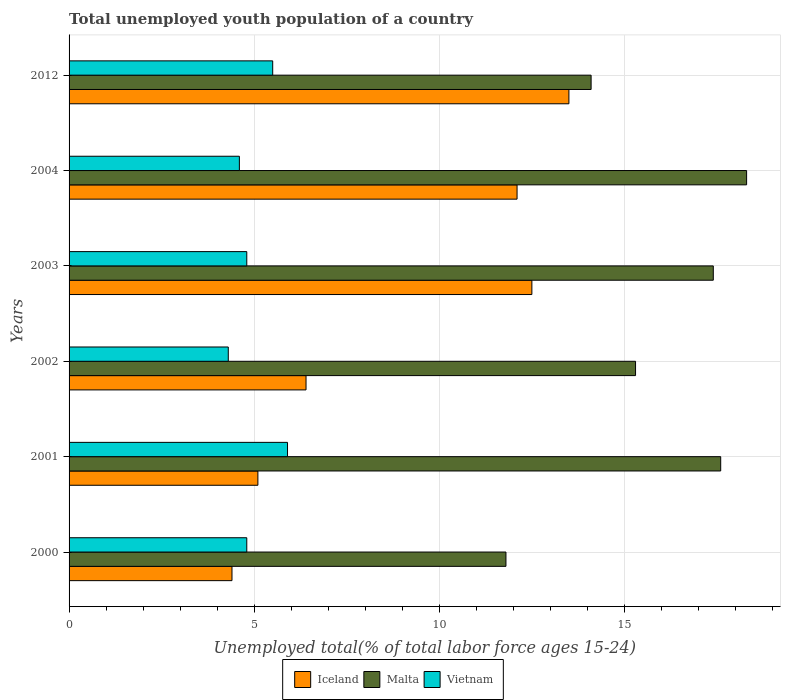How many groups of bars are there?
Give a very brief answer. 6. How many bars are there on the 5th tick from the top?
Provide a short and direct response. 3. How many bars are there on the 1st tick from the bottom?
Offer a very short reply. 3. What is the label of the 3rd group of bars from the top?
Give a very brief answer. 2003. In how many cases, is the number of bars for a given year not equal to the number of legend labels?
Make the answer very short. 0. What is the percentage of total unemployed youth population of a country in Vietnam in 2004?
Keep it short and to the point. 4.6. Across all years, what is the minimum percentage of total unemployed youth population of a country in Vietnam?
Give a very brief answer. 4.3. In which year was the percentage of total unemployed youth population of a country in Malta maximum?
Your answer should be compact. 2004. What is the total percentage of total unemployed youth population of a country in Vietnam in the graph?
Make the answer very short. 29.9. What is the difference between the percentage of total unemployed youth population of a country in Iceland in 2002 and that in 2012?
Your answer should be compact. -7.1. What is the difference between the percentage of total unemployed youth population of a country in Iceland in 2000 and the percentage of total unemployed youth population of a country in Vietnam in 2002?
Your answer should be very brief. 0.1. What is the average percentage of total unemployed youth population of a country in Iceland per year?
Provide a succinct answer. 9. In the year 2001, what is the difference between the percentage of total unemployed youth population of a country in Iceland and percentage of total unemployed youth population of a country in Malta?
Your answer should be very brief. -12.5. In how many years, is the percentage of total unemployed youth population of a country in Vietnam greater than 17 %?
Provide a short and direct response. 0. What is the ratio of the percentage of total unemployed youth population of a country in Malta in 2003 to that in 2012?
Your answer should be very brief. 1.23. Is the percentage of total unemployed youth population of a country in Vietnam in 2001 less than that in 2002?
Ensure brevity in your answer.  No. What is the difference between the highest and the second highest percentage of total unemployed youth population of a country in Malta?
Provide a short and direct response. 0.7. What is the difference between the highest and the lowest percentage of total unemployed youth population of a country in Vietnam?
Make the answer very short. 1.6. In how many years, is the percentage of total unemployed youth population of a country in Malta greater than the average percentage of total unemployed youth population of a country in Malta taken over all years?
Keep it short and to the point. 3. Is the sum of the percentage of total unemployed youth population of a country in Vietnam in 2001 and 2002 greater than the maximum percentage of total unemployed youth population of a country in Malta across all years?
Ensure brevity in your answer.  No. What does the 2nd bar from the top in 2012 represents?
Your answer should be very brief. Malta. What does the 2nd bar from the bottom in 2004 represents?
Your answer should be very brief. Malta. Is it the case that in every year, the sum of the percentage of total unemployed youth population of a country in Malta and percentage of total unemployed youth population of a country in Iceland is greater than the percentage of total unemployed youth population of a country in Vietnam?
Provide a succinct answer. Yes. How many bars are there?
Provide a succinct answer. 18. Does the graph contain any zero values?
Your answer should be compact. No. Where does the legend appear in the graph?
Provide a succinct answer. Bottom center. What is the title of the graph?
Offer a terse response. Total unemployed youth population of a country. What is the label or title of the X-axis?
Your answer should be compact. Unemployed total(% of total labor force ages 15-24). What is the label or title of the Y-axis?
Provide a succinct answer. Years. What is the Unemployed total(% of total labor force ages 15-24) of Iceland in 2000?
Your response must be concise. 4.4. What is the Unemployed total(% of total labor force ages 15-24) of Malta in 2000?
Your answer should be very brief. 11.8. What is the Unemployed total(% of total labor force ages 15-24) of Vietnam in 2000?
Ensure brevity in your answer.  4.8. What is the Unemployed total(% of total labor force ages 15-24) of Iceland in 2001?
Keep it short and to the point. 5.1. What is the Unemployed total(% of total labor force ages 15-24) of Malta in 2001?
Ensure brevity in your answer.  17.6. What is the Unemployed total(% of total labor force ages 15-24) of Vietnam in 2001?
Your answer should be compact. 5.9. What is the Unemployed total(% of total labor force ages 15-24) of Iceland in 2002?
Give a very brief answer. 6.4. What is the Unemployed total(% of total labor force ages 15-24) in Malta in 2002?
Your response must be concise. 15.3. What is the Unemployed total(% of total labor force ages 15-24) in Vietnam in 2002?
Your answer should be compact. 4.3. What is the Unemployed total(% of total labor force ages 15-24) of Iceland in 2003?
Give a very brief answer. 12.5. What is the Unemployed total(% of total labor force ages 15-24) in Malta in 2003?
Offer a terse response. 17.4. What is the Unemployed total(% of total labor force ages 15-24) in Vietnam in 2003?
Provide a succinct answer. 4.8. What is the Unemployed total(% of total labor force ages 15-24) of Iceland in 2004?
Your response must be concise. 12.1. What is the Unemployed total(% of total labor force ages 15-24) of Malta in 2004?
Keep it short and to the point. 18.3. What is the Unemployed total(% of total labor force ages 15-24) in Vietnam in 2004?
Your answer should be compact. 4.6. What is the Unemployed total(% of total labor force ages 15-24) of Iceland in 2012?
Keep it short and to the point. 13.5. What is the Unemployed total(% of total labor force ages 15-24) of Malta in 2012?
Provide a succinct answer. 14.1. What is the Unemployed total(% of total labor force ages 15-24) of Vietnam in 2012?
Offer a very short reply. 5.5. Across all years, what is the maximum Unemployed total(% of total labor force ages 15-24) in Iceland?
Your answer should be very brief. 13.5. Across all years, what is the maximum Unemployed total(% of total labor force ages 15-24) in Malta?
Your answer should be very brief. 18.3. Across all years, what is the maximum Unemployed total(% of total labor force ages 15-24) in Vietnam?
Your answer should be very brief. 5.9. Across all years, what is the minimum Unemployed total(% of total labor force ages 15-24) in Iceland?
Your answer should be compact. 4.4. Across all years, what is the minimum Unemployed total(% of total labor force ages 15-24) of Malta?
Keep it short and to the point. 11.8. Across all years, what is the minimum Unemployed total(% of total labor force ages 15-24) of Vietnam?
Provide a short and direct response. 4.3. What is the total Unemployed total(% of total labor force ages 15-24) of Iceland in the graph?
Offer a terse response. 54. What is the total Unemployed total(% of total labor force ages 15-24) of Malta in the graph?
Provide a short and direct response. 94.5. What is the total Unemployed total(% of total labor force ages 15-24) in Vietnam in the graph?
Ensure brevity in your answer.  29.9. What is the difference between the Unemployed total(% of total labor force ages 15-24) of Vietnam in 2000 and that in 2001?
Offer a terse response. -1.1. What is the difference between the Unemployed total(% of total labor force ages 15-24) in Iceland in 2000 and that in 2002?
Your response must be concise. -2. What is the difference between the Unemployed total(% of total labor force ages 15-24) in Vietnam in 2000 and that in 2002?
Your response must be concise. 0.5. What is the difference between the Unemployed total(% of total labor force ages 15-24) of Iceland in 2000 and that in 2003?
Give a very brief answer. -8.1. What is the difference between the Unemployed total(% of total labor force ages 15-24) of Malta in 2000 and that in 2003?
Your answer should be compact. -5.6. What is the difference between the Unemployed total(% of total labor force ages 15-24) in Vietnam in 2000 and that in 2003?
Your answer should be compact. 0. What is the difference between the Unemployed total(% of total labor force ages 15-24) in Malta in 2000 and that in 2004?
Make the answer very short. -6.5. What is the difference between the Unemployed total(% of total labor force ages 15-24) in Vietnam in 2000 and that in 2012?
Give a very brief answer. -0.7. What is the difference between the Unemployed total(% of total labor force ages 15-24) in Vietnam in 2001 and that in 2003?
Make the answer very short. 1.1. What is the difference between the Unemployed total(% of total labor force ages 15-24) in Malta in 2001 and that in 2004?
Make the answer very short. -0.7. What is the difference between the Unemployed total(% of total labor force ages 15-24) of Malta in 2001 and that in 2012?
Make the answer very short. 3.5. What is the difference between the Unemployed total(% of total labor force ages 15-24) in Iceland in 2002 and that in 2003?
Keep it short and to the point. -6.1. What is the difference between the Unemployed total(% of total labor force ages 15-24) in Malta in 2002 and that in 2003?
Ensure brevity in your answer.  -2.1. What is the difference between the Unemployed total(% of total labor force ages 15-24) of Vietnam in 2002 and that in 2003?
Give a very brief answer. -0.5. What is the difference between the Unemployed total(% of total labor force ages 15-24) in Iceland in 2002 and that in 2004?
Offer a terse response. -5.7. What is the difference between the Unemployed total(% of total labor force ages 15-24) in Vietnam in 2002 and that in 2004?
Keep it short and to the point. -0.3. What is the difference between the Unemployed total(% of total labor force ages 15-24) of Iceland in 2002 and that in 2012?
Give a very brief answer. -7.1. What is the difference between the Unemployed total(% of total labor force ages 15-24) of Vietnam in 2002 and that in 2012?
Provide a succinct answer. -1.2. What is the difference between the Unemployed total(% of total labor force ages 15-24) in Iceland in 2003 and that in 2004?
Give a very brief answer. 0.4. What is the difference between the Unemployed total(% of total labor force ages 15-24) of Iceland in 2003 and that in 2012?
Provide a short and direct response. -1. What is the difference between the Unemployed total(% of total labor force ages 15-24) in Vietnam in 2003 and that in 2012?
Your answer should be very brief. -0.7. What is the difference between the Unemployed total(% of total labor force ages 15-24) in Malta in 2004 and that in 2012?
Your answer should be very brief. 4.2. What is the difference between the Unemployed total(% of total labor force ages 15-24) of Vietnam in 2004 and that in 2012?
Offer a terse response. -0.9. What is the difference between the Unemployed total(% of total labor force ages 15-24) in Iceland in 2000 and the Unemployed total(% of total labor force ages 15-24) in Malta in 2001?
Your answer should be very brief. -13.2. What is the difference between the Unemployed total(% of total labor force ages 15-24) of Iceland in 2000 and the Unemployed total(% of total labor force ages 15-24) of Vietnam in 2002?
Give a very brief answer. 0.1. What is the difference between the Unemployed total(% of total labor force ages 15-24) of Malta in 2000 and the Unemployed total(% of total labor force ages 15-24) of Vietnam in 2002?
Your response must be concise. 7.5. What is the difference between the Unemployed total(% of total labor force ages 15-24) of Iceland in 2000 and the Unemployed total(% of total labor force ages 15-24) of Vietnam in 2003?
Provide a succinct answer. -0.4. What is the difference between the Unemployed total(% of total labor force ages 15-24) of Malta in 2000 and the Unemployed total(% of total labor force ages 15-24) of Vietnam in 2003?
Your answer should be compact. 7. What is the difference between the Unemployed total(% of total labor force ages 15-24) of Iceland in 2000 and the Unemployed total(% of total labor force ages 15-24) of Vietnam in 2004?
Give a very brief answer. -0.2. What is the difference between the Unemployed total(% of total labor force ages 15-24) in Malta in 2000 and the Unemployed total(% of total labor force ages 15-24) in Vietnam in 2004?
Offer a terse response. 7.2. What is the difference between the Unemployed total(% of total labor force ages 15-24) in Iceland in 2000 and the Unemployed total(% of total labor force ages 15-24) in Vietnam in 2012?
Offer a terse response. -1.1. What is the difference between the Unemployed total(% of total labor force ages 15-24) of Iceland in 2001 and the Unemployed total(% of total labor force ages 15-24) of Malta in 2002?
Provide a short and direct response. -10.2. What is the difference between the Unemployed total(% of total labor force ages 15-24) in Iceland in 2001 and the Unemployed total(% of total labor force ages 15-24) in Vietnam in 2002?
Your answer should be very brief. 0.8. What is the difference between the Unemployed total(% of total labor force ages 15-24) in Iceland in 2001 and the Unemployed total(% of total labor force ages 15-24) in Vietnam in 2003?
Offer a terse response. 0.3. What is the difference between the Unemployed total(% of total labor force ages 15-24) in Malta in 2001 and the Unemployed total(% of total labor force ages 15-24) in Vietnam in 2003?
Provide a short and direct response. 12.8. What is the difference between the Unemployed total(% of total labor force ages 15-24) in Iceland in 2001 and the Unemployed total(% of total labor force ages 15-24) in Malta in 2012?
Provide a succinct answer. -9. What is the difference between the Unemployed total(% of total labor force ages 15-24) in Iceland in 2001 and the Unemployed total(% of total labor force ages 15-24) in Vietnam in 2012?
Make the answer very short. -0.4. What is the difference between the Unemployed total(% of total labor force ages 15-24) in Malta in 2001 and the Unemployed total(% of total labor force ages 15-24) in Vietnam in 2012?
Your response must be concise. 12.1. What is the difference between the Unemployed total(% of total labor force ages 15-24) of Iceland in 2002 and the Unemployed total(% of total labor force ages 15-24) of Malta in 2003?
Your answer should be compact. -11. What is the difference between the Unemployed total(% of total labor force ages 15-24) of Iceland in 2002 and the Unemployed total(% of total labor force ages 15-24) of Vietnam in 2004?
Your answer should be compact. 1.8. What is the difference between the Unemployed total(% of total labor force ages 15-24) in Malta in 2002 and the Unemployed total(% of total labor force ages 15-24) in Vietnam in 2004?
Your answer should be very brief. 10.7. What is the difference between the Unemployed total(% of total labor force ages 15-24) in Iceland in 2002 and the Unemployed total(% of total labor force ages 15-24) in Vietnam in 2012?
Offer a very short reply. 0.9. What is the difference between the Unemployed total(% of total labor force ages 15-24) in Malta in 2002 and the Unemployed total(% of total labor force ages 15-24) in Vietnam in 2012?
Give a very brief answer. 9.8. What is the difference between the Unemployed total(% of total labor force ages 15-24) in Iceland in 2003 and the Unemployed total(% of total labor force ages 15-24) in Malta in 2004?
Provide a short and direct response. -5.8. What is the difference between the Unemployed total(% of total labor force ages 15-24) in Iceland in 2003 and the Unemployed total(% of total labor force ages 15-24) in Vietnam in 2004?
Keep it short and to the point. 7.9. What is the difference between the Unemployed total(% of total labor force ages 15-24) in Malta in 2003 and the Unemployed total(% of total labor force ages 15-24) in Vietnam in 2004?
Ensure brevity in your answer.  12.8. What is the difference between the Unemployed total(% of total labor force ages 15-24) of Iceland in 2003 and the Unemployed total(% of total labor force ages 15-24) of Malta in 2012?
Give a very brief answer. -1.6. What is the difference between the Unemployed total(% of total labor force ages 15-24) of Malta in 2004 and the Unemployed total(% of total labor force ages 15-24) of Vietnam in 2012?
Your answer should be compact. 12.8. What is the average Unemployed total(% of total labor force ages 15-24) in Iceland per year?
Your answer should be compact. 9. What is the average Unemployed total(% of total labor force ages 15-24) of Malta per year?
Offer a very short reply. 15.75. What is the average Unemployed total(% of total labor force ages 15-24) of Vietnam per year?
Your response must be concise. 4.98. In the year 2000, what is the difference between the Unemployed total(% of total labor force ages 15-24) in Iceland and Unemployed total(% of total labor force ages 15-24) in Malta?
Provide a succinct answer. -7.4. In the year 2001, what is the difference between the Unemployed total(% of total labor force ages 15-24) in Iceland and Unemployed total(% of total labor force ages 15-24) in Vietnam?
Provide a short and direct response. -0.8. In the year 2001, what is the difference between the Unemployed total(% of total labor force ages 15-24) in Malta and Unemployed total(% of total labor force ages 15-24) in Vietnam?
Give a very brief answer. 11.7. In the year 2002, what is the difference between the Unemployed total(% of total labor force ages 15-24) of Iceland and Unemployed total(% of total labor force ages 15-24) of Malta?
Keep it short and to the point. -8.9. In the year 2002, what is the difference between the Unemployed total(% of total labor force ages 15-24) of Iceland and Unemployed total(% of total labor force ages 15-24) of Vietnam?
Your response must be concise. 2.1. In the year 2003, what is the difference between the Unemployed total(% of total labor force ages 15-24) in Iceland and Unemployed total(% of total labor force ages 15-24) in Vietnam?
Your response must be concise. 7.7. In the year 2003, what is the difference between the Unemployed total(% of total labor force ages 15-24) of Malta and Unemployed total(% of total labor force ages 15-24) of Vietnam?
Offer a terse response. 12.6. In the year 2004, what is the difference between the Unemployed total(% of total labor force ages 15-24) in Iceland and Unemployed total(% of total labor force ages 15-24) in Malta?
Offer a terse response. -6.2. In the year 2012, what is the difference between the Unemployed total(% of total labor force ages 15-24) of Iceland and Unemployed total(% of total labor force ages 15-24) of Malta?
Your response must be concise. -0.6. In the year 2012, what is the difference between the Unemployed total(% of total labor force ages 15-24) in Iceland and Unemployed total(% of total labor force ages 15-24) in Vietnam?
Provide a succinct answer. 8. In the year 2012, what is the difference between the Unemployed total(% of total labor force ages 15-24) of Malta and Unemployed total(% of total labor force ages 15-24) of Vietnam?
Provide a succinct answer. 8.6. What is the ratio of the Unemployed total(% of total labor force ages 15-24) in Iceland in 2000 to that in 2001?
Ensure brevity in your answer.  0.86. What is the ratio of the Unemployed total(% of total labor force ages 15-24) of Malta in 2000 to that in 2001?
Make the answer very short. 0.67. What is the ratio of the Unemployed total(% of total labor force ages 15-24) of Vietnam in 2000 to that in 2001?
Provide a short and direct response. 0.81. What is the ratio of the Unemployed total(% of total labor force ages 15-24) of Iceland in 2000 to that in 2002?
Your response must be concise. 0.69. What is the ratio of the Unemployed total(% of total labor force ages 15-24) of Malta in 2000 to that in 2002?
Make the answer very short. 0.77. What is the ratio of the Unemployed total(% of total labor force ages 15-24) in Vietnam in 2000 to that in 2002?
Your response must be concise. 1.12. What is the ratio of the Unemployed total(% of total labor force ages 15-24) of Iceland in 2000 to that in 2003?
Give a very brief answer. 0.35. What is the ratio of the Unemployed total(% of total labor force ages 15-24) of Malta in 2000 to that in 2003?
Provide a succinct answer. 0.68. What is the ratio of the Unemployed total(% of total labor force ages 15-24) of Iceland in 2000 to that in 2004?
Your response must be concise. 0.36. What is the ratio of the Unemployed total(% of total labor force ages 15-24) in Malta in 2000 to that in 2004?
Keep it short and to the point. 0.64. What is the ratio of the Unemployed total(% of total labor force ages 15-24) of Vietnam in 2000 to that in 2004?
Provide a succinct answer. 1.04. What is the ratio of the Unemployed total(% of total labor force ages 15-24) in Iceland in 2000 to that in 2012?
Your answer should be compact. 0.33. What is the ratio of the Unemployed total(% of total labor force ages 15-24) in Malta in 2000 to that in 2012?
Your response must be concise. 0.84. What is the ratio of the Unemployed total(% of total labor force ages 15-24) in Vietnam in 2000 to that in 2012?
Ensure brevity in your answer.  0.87. What is the ratio of the Unemployed total(% of total labor force ages 15-24) in Iceland in 2001 to that in 2002?
Give a very brief answer. 0.8. What is the ratio of the Unemployed total(% of total labor force ages 15-24) of Malta in 2001 to that in 2002?
Give a very brief answer. 1.15. What is the ratio of the Unemployed total(% of total labor force ages 15-24) of Vietnam in 2001 to that in 2002?
Give a very brief answer. 1.37. What is the ratio of the Unemployed total(% of total labor force ages 15-24) in Iceland in 2001 to that in 2003?
Give a very brief answer. 0.41. What is the ratio of the Unemployed total(% of total labor force ages 15-24) of Malta in 2001 to that in 2003?
Offer a terse response. 1.01. What is the ratio of the Unemployed total(% of total labor force ages 15-24) in Vietnam in 2001 to that in 2003?
Offer a very short reply. 1.23. What is the ratio of the Unemployed total(% of total labor force ages 15-24) in Iceland in 2001 to that in 2004?
Ensure brevity in your answer.  0.42. What is the ratio of the Unemployed total(% of total labor force ages 15-24) in Malta in 2001 to that in 2004?
Your answer should be compact. 0.96. What is the ratio of the Unemployed total(% of total labor force ages 15-24) of Vietnam in 2001 to that in 2004?
Provide a succinct answer. 1.28. What is the ratio of the Unemployed total(% of total labor force ages 15-24) in Iceland in 2001 to that in 2012?
Your response must be concise. 0.38. What is the ratio of the Unemployed total(% of total labor force ages 15-24) of Malta in 2001 to that in 2012?
Your response must be concise. 1.25. What is the ratio of the Unemployed total(% of total labor force ages 15-24) of Vietnam in 2001 to that in 2012?
Make the answer very short. 1.07. What is the ratio of the Unemployed total(% of total labor force ages 15-24) in Iceland in 2002 to that in 2003?
Your response must be concise. 0.51. What is the ratio of the Unemployed total(% of total labor force ages 15-24) in Malta in 2002 to that in 2003?
Ensure brevity in your answer.  0.88. What is the ratio of the Unemployed total(% of total labor force ages 15-24) of Vietnam in 2002 to that in 2003?
Offer a terse response. 0.9. What is the ratio of the Unemployed total(% of total labor force ages 15-24) of Iceland in 2002 to that in 2004?
Your answer should be compact. 0.53. What is the ratio of the Unemployed total(% of total labor force ages 15-24) of Malta in 2002 to that in 2004?
Keep it short and to the point. 0.84. What is the ratio of the Unemployed total(% of total labor force ages 15-24) of Vietnam in 2002 to that in 2004?
Keep it short and to the point. 0.93. What is the ratio of the Unemployed total(% of total labor force ages 15-24) in Iceland in 2002 to that in 2012?
Give a very brief answer. 0.47. What is the ratio of the Unemployed total(% of total labor force ages 15-24) of Malta in 2002 to that in 2012?
Give a very brief answer. 1.09. What is the ratio of the Unemployed total(% of total labor force ages 15-24) of Vietnam in 2002 to that in 2012?
Ensure brevity in your answer.  0.78. What is the ratio of the Unemployed total(% of total labor force ages 15-24) of Iceland in 2003 to that in 2004?
Give a very brief answer. 1.03. What is the ratio of the Unemployed total(% of total labor force ages 15-24) of Malta in 2003 to that in 2004?
Provide a succinct answer. 0.95. What is the ratio of the Unemployed total(% of total labor force ages 15-24) of Vietnam in 2003 to that in 2004?
Provide a short and direct response. 1.04. What is the ratio of the Unemployed total(% of total labor force ages 15-24) of Iceland in 2003 to that in 2012?
Provide a short and direct response. 0.93. What is the ratio of the Unemployed total(% of total labor force ages 15-24) of Malta in 2003 to that in 2012?
Keep it short and to the point. 1.23. What is the ratio of the Unemployed total(% of total labor force ages 15-24) in Vietnam in 2003 to that in 2012?
Your answer should be compact. 0.87. What is the ratio of the Unemployed total(% of total labor force ages 15-24) of Iceland in 2004 to that in 2012?
Provide a succinct answer. 0.9. What is the ratio of the Unemployed total(% of total labor force ages 15-24) in Malta in 2004 to that in 2012?
Provide a succinct answer. 1.3. What is the ratio of the Unemployed total(% of total labor force ages 15-24) in Vietnam in 2004 to that in 2012?
Give a very brief answer. 0.84. What is the difference between the highest and the second highest Unemployed total(% of total labor force ages 15-24) in Iceland?
Provide a short and direct response. 1. What is the difference between the highest and the second highest Unemployed total(% of total labor force ages 15-24) in Malta?
Your answer should be compact. 0.7. 